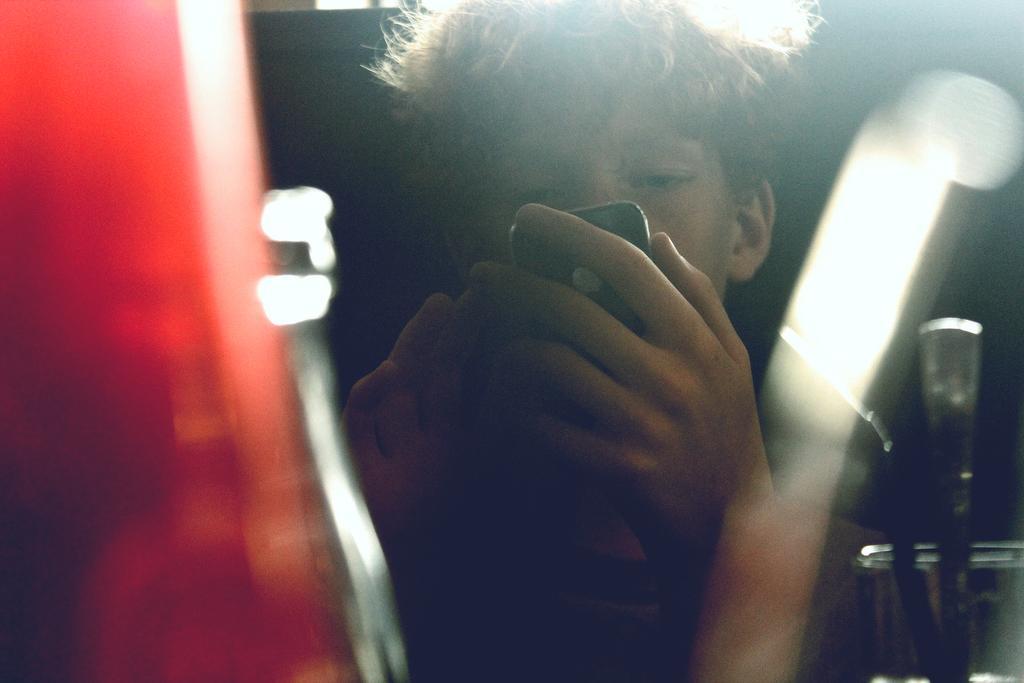Please provide a concise description of this image. In this image we can see a person is sitting and holding a mobile in the hands, there is a glass and spoon in it, the background is blurry. 